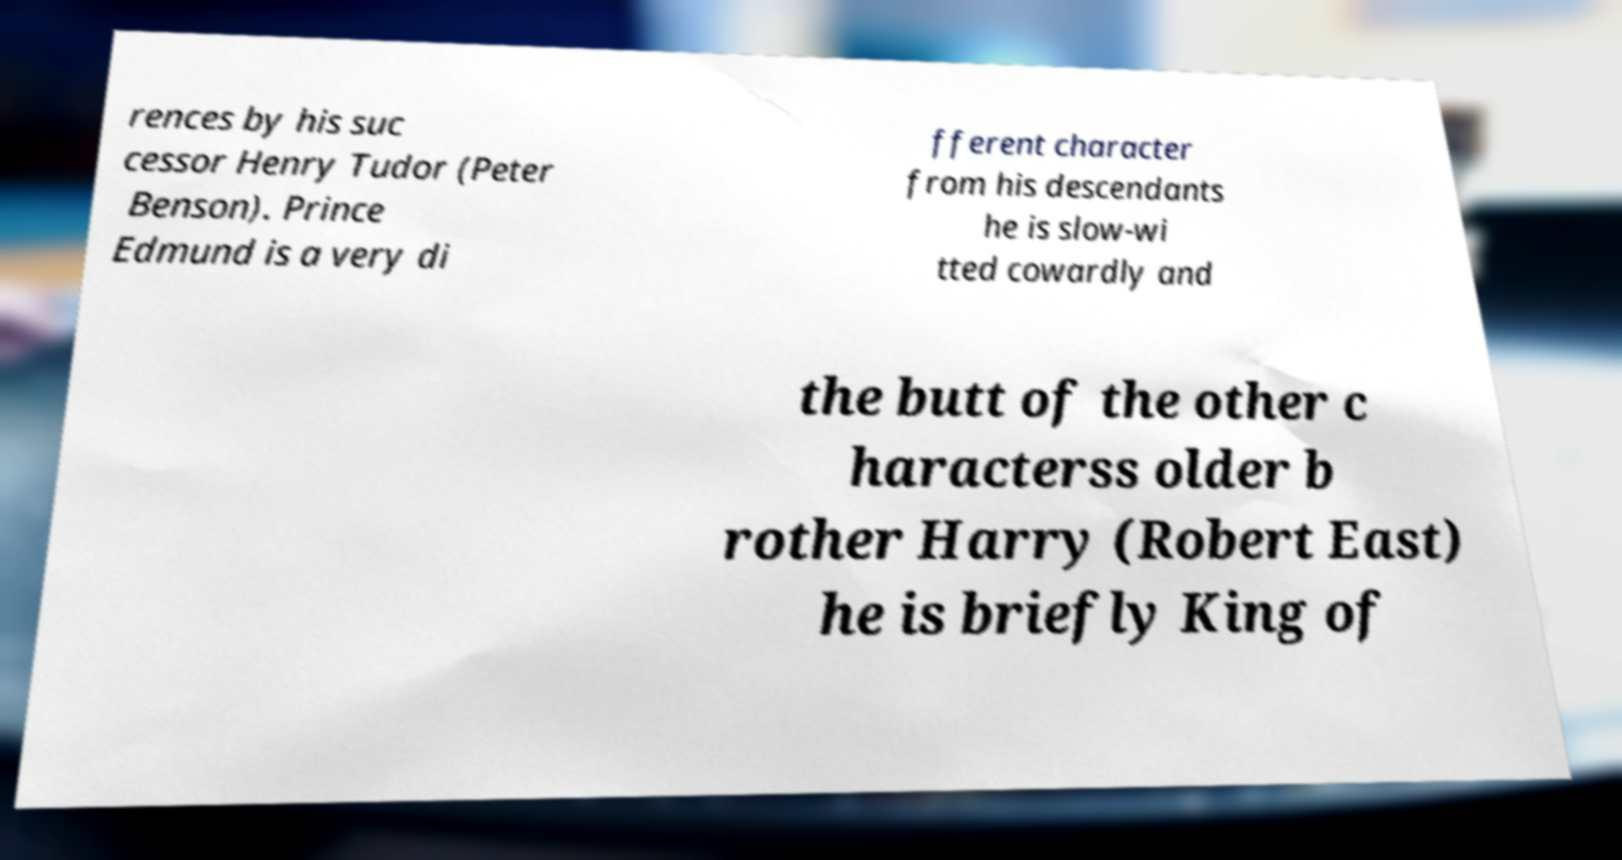Could you assist in decoding the text presented in this image and type it out clearly? rences by his suc cessor Henry Tudor (Peter Benson). Prince Edmund is a very di fferent character from his descendants he is slow-wi tted cowardly and the butt of the other c haracterss older b rother Harry (Robert East) he is briefly King of 